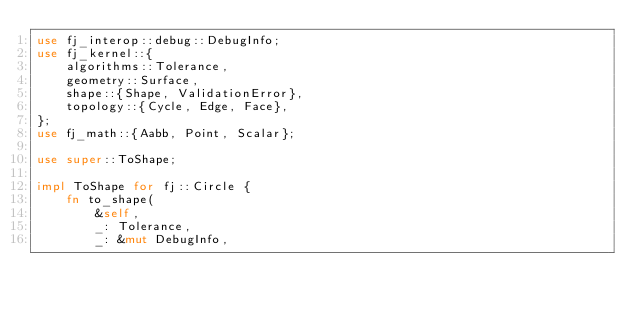Convert code to text. <code><loc_0><loc_0><loc_500><loc_500><_Rust_>use fj_interop::debug::DebugInfo;
use fj_kernel::{
    algorithms::Tolerance,
    geometry::Surface,
    shape::{Shape, ValidationError},
    topology::{Cycle, Edge, Face},
};
use fj_math::{Aabb, Point, Scalar};

use super::ToShape;

impl ToShape for fj::Circle {
    fn to_shape(
        &self,
        _: Tolerance,
        _: &mut DebugInfo,</code> 